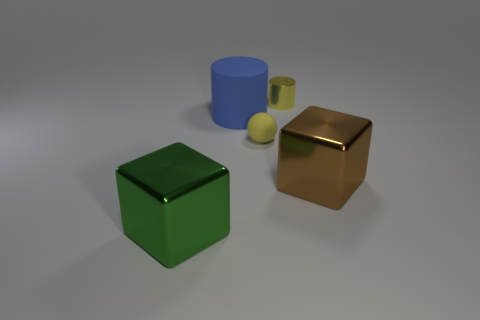What is the size of the yellow object behind the rubber ball?
Keep it short and to the point. Small. Are there an equal number of cylinders in front of the green metal cube and large purple metallic cubes?
Your response must be concise. Yes. Is there a small gray rubber object that has the same shape as the large blue matte object?
Your answer should be compact. No. The shiny thing that is both left of the brown cube and to the right of the blue thing has what shape?
Provide a short and direct response. Cylinder. Is the yellow cylinder made of the same material as the brown block that is behind the large green block?
Make the answer very short. Yes. There is a brown metallic object; are there any small yellow things in front of it?
Give a very brief answer. No. How many objects are either cyan rubber cylinders or metal things that are left of the large matte cylinder?
Offer a very short reply. 1. The metallic cube on the right side of the shiny thing in front of the brown thing is what color?
Provide a succinct answer. Brown. How many other things are made of the same material as the small cylinder?
Offer a terse response. 2. How many metal objects are green things or big cubes?
Keep it short and to the point. 2. 